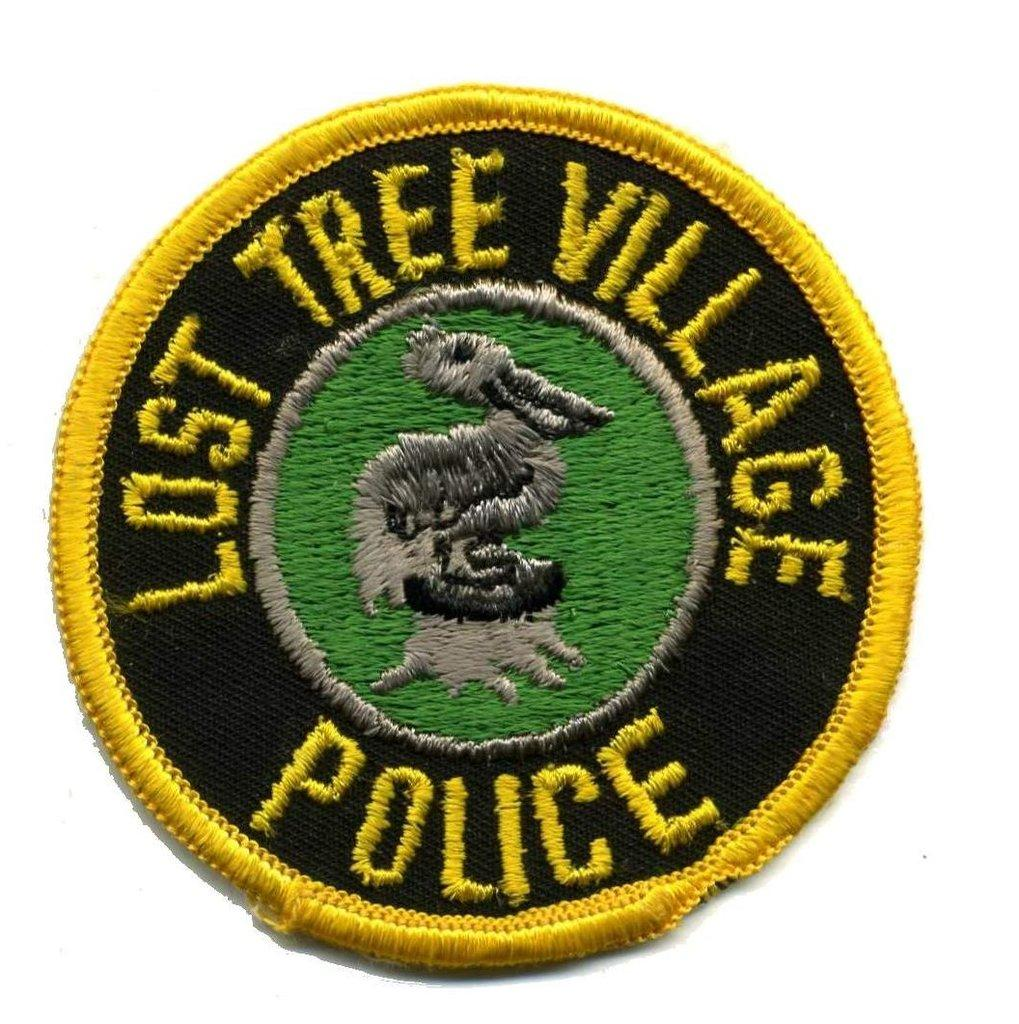What is the main feature of the image? There is a logo in the image. What color is the background of the image? The background of the image is white. What invention is being advertised by the logo in the image? There is no specific invention mentioned or implied in the image; it only contains a logo. How many cards are visible in the image? There are no cards present in the image. 